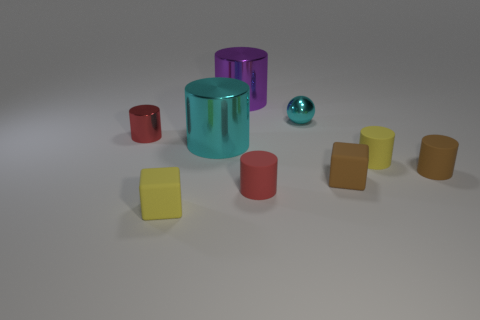Which object stands out the most in this arrangement and why? The most prominent object is the large cyan cylinder in the center because of its size, central position, and reflective surface that draws the eye. Its bright color contrasts with the more muted shades of the other objects, making it a focal point in this composition. 